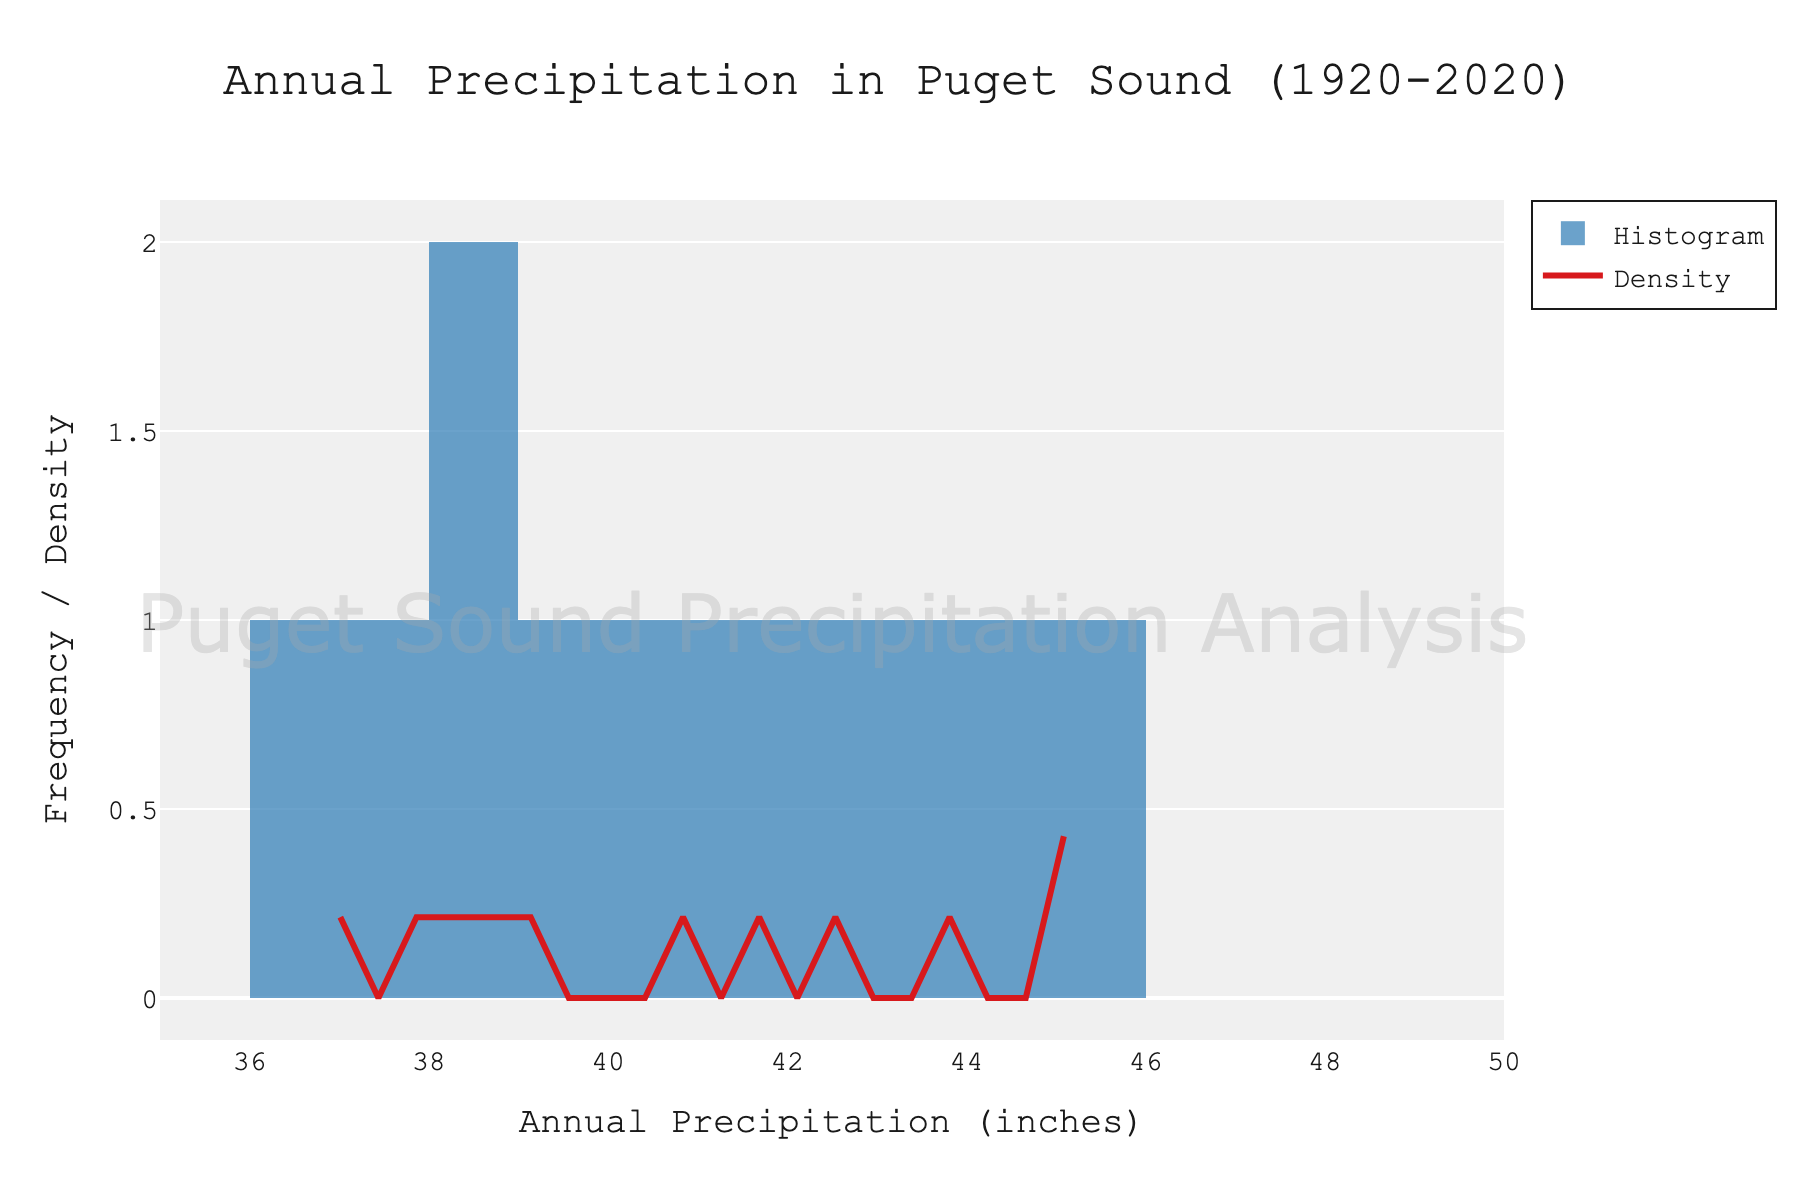What is the title of the figure? The title is located at the top of the figure and is centered. It is written as "Annual Precipitation in Puget Sound (1920-2020)".
Answer: Annual Precipitation in Puget Sound (1920-2020) What does the x-axis represent? The x-axis is labeled "Annual Precipitation (inches)", indicating it measures the yearly rainfall in inches.
Answer: Annual Precipitation (inches) What colors are used for the histogram and the density curve? The histogram bars are colored in blue, and the density curve is red. The figure uses these distinct colors to differentiate between the two elements.
Answer: Blue and Red How many bins are used for the histogram? The histogram is divided into 10 bins, which group the data points based on their precipitation values.
Answer: 10 What is the approximate range of annual precipitation values shown on the x-axis? The x-axis ranges from about 35 inches to 50 inches, encompassing the variation in annual precipitation values over the century.
Answer: 35 to 50 inches Which precipitation value range appears to have the highest density according to the KDE curve? By observing the peak of the density curve, the range with the highest density is around 39 to 41 inches, as this is where the density curve reaches its maximum point.
Answer: 39 to 41 inches In the histogram, which precipitation value appears most frequently? The highest bar in the histogram represents the most frequent precipitation value, which is around 39 to 41 inches.
Answer: 39 to 41 inches What is the approximate height of the highest peak on the density curve? The peak height of the density curve appears to be slightly below 0.1, indicating the highest density of precipitation values within a specific range.
Answer: Slightly below 0.1 Is the distribution of annual precipitation in Puget Sound more likely to be skewed or symmetric based on the figure? The histogram and density curve suggest a slightly skewed distribution as there are more values concentrated towards the lower end of the range (around 38 inches), causing a slight leftward skew.
Answer: Slightly skewed From the density curve, between which two precipitation values does the curve remain relatively flat? The density curve is relatively flat between 43 and 45 inches, indicating fewer data points or a more consistent distribution of annual precipitation within this range.
Answer: 43 and 45 inches 